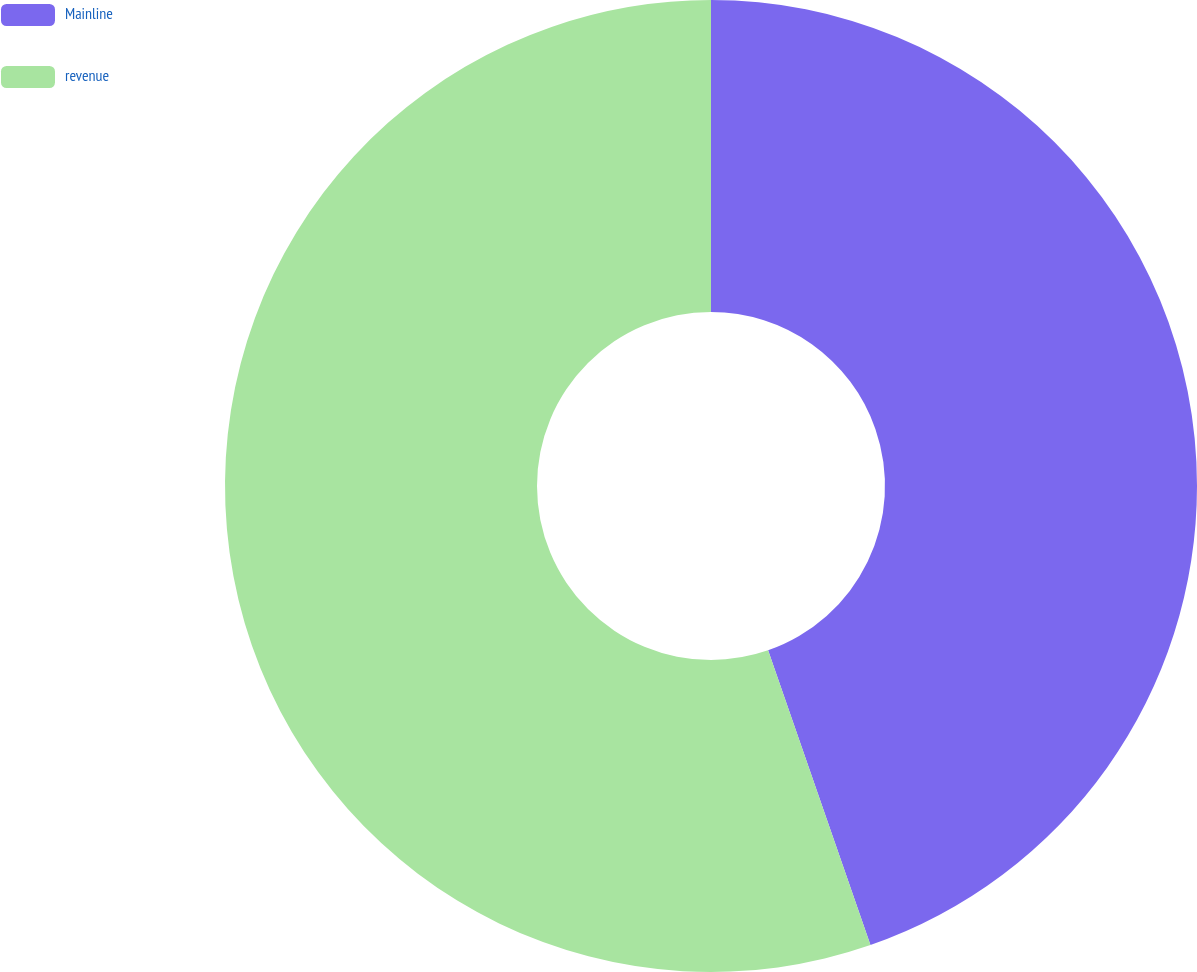Convert chart to OTSL. <chart><loc_0><loc_0><loc_500><loc_500><pie_chart><fcel>Mainline<fcel>revenue<nl><fcel>44.68%<fcel>55.32%<nl></chart> 